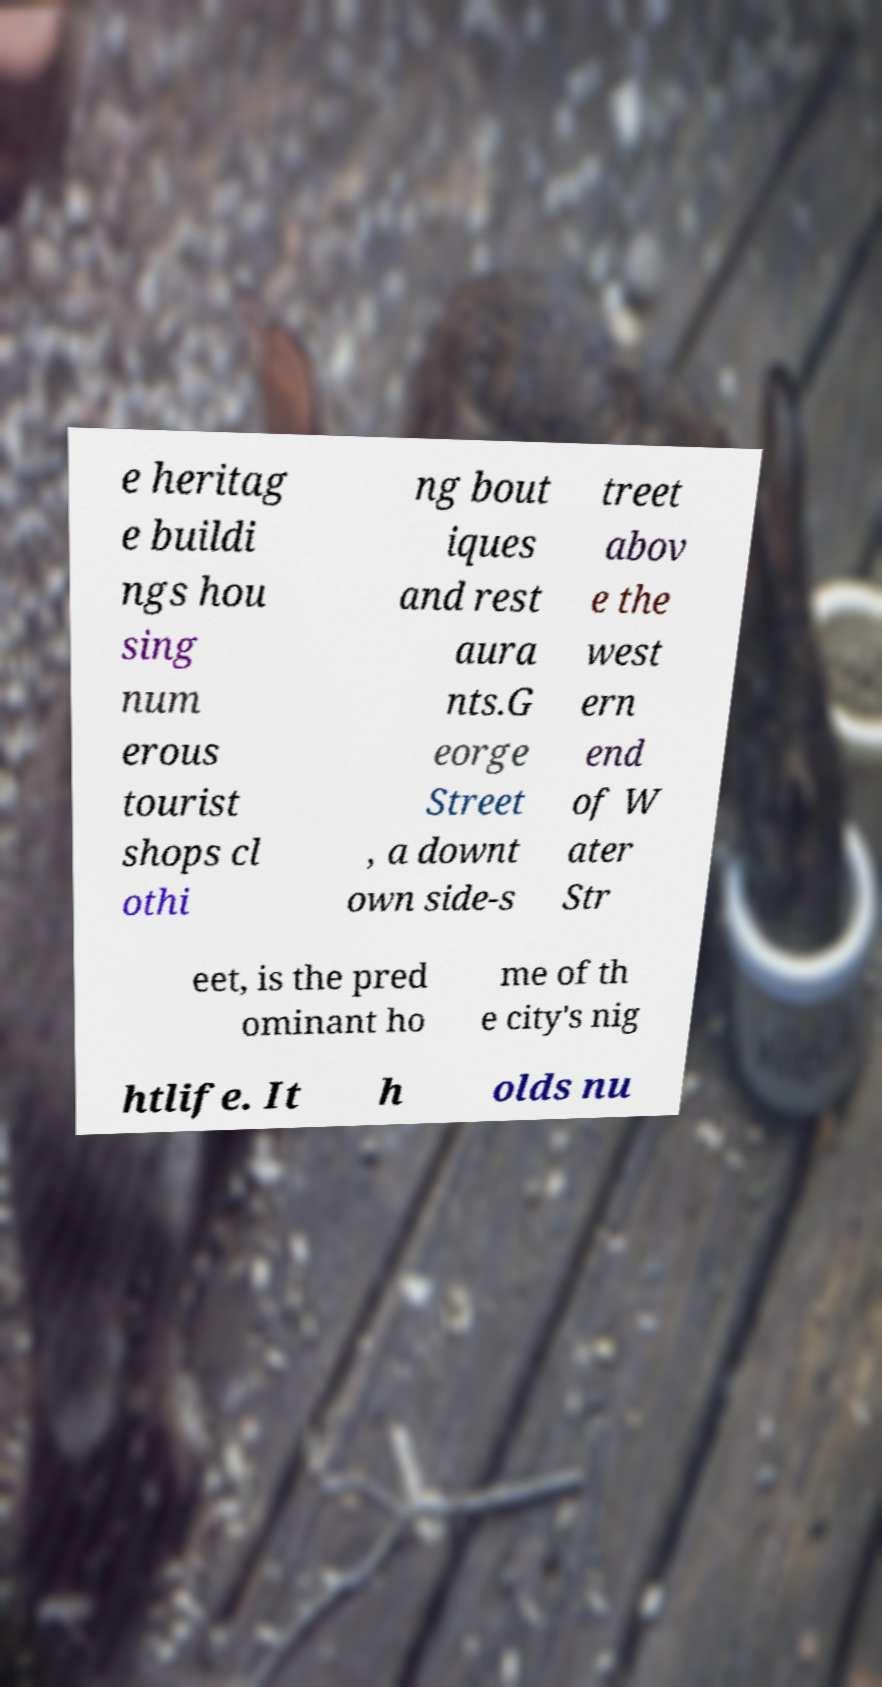Please read and relay the text visible in this image. What does it say? e heritag e buildi ngs hou sing num erous tourist shops cl othi ng bout iques and rest aura nts.G eorge Street , a downt own side-s treet abov e the west ern end of W ater Str eet, is the pred ominant ho me of th e city's nig htlife. It h olds nu 